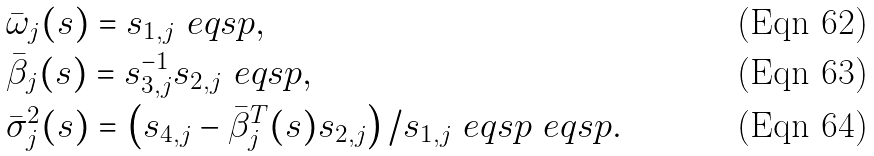<formula> <loc_0><loc_0><loc_500><loc_500>& \bar { \omega } _ { j } ( s ) = s _ { 1 , j } \ e q s p , \\ & \bar { \beta } _ { j } ( s ) = s _ { 3 , j } ^ { - 1 } s _ { 2 , j } \ e q s p , \\ & \bar { \sigma } _ { j } ^ { 2 } ( s ) = \left ( s _ { 4 , j } - \bar { \beta } _ { j } ^ { T } ( s ) s _ { 2 , j } \right ) / s _ { 1 , j } \ e q s p \ e q s p .</formula> 